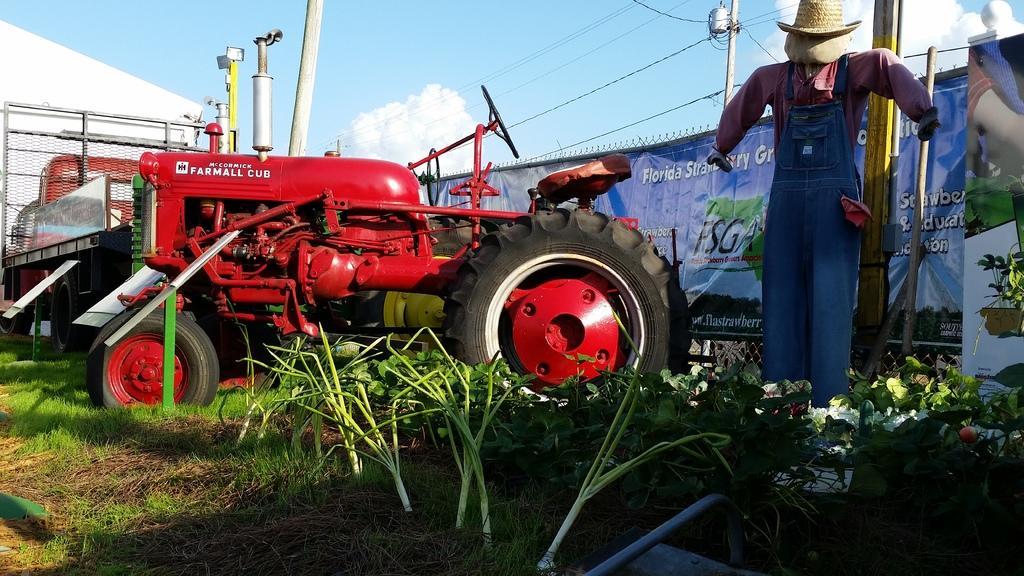Describe this image in one or two sentences. This picture shows a tractor and we see plants and grass on the ground and a banner on the back and we see a cloudy sky and few poles and a scarecrow and we see a house. 